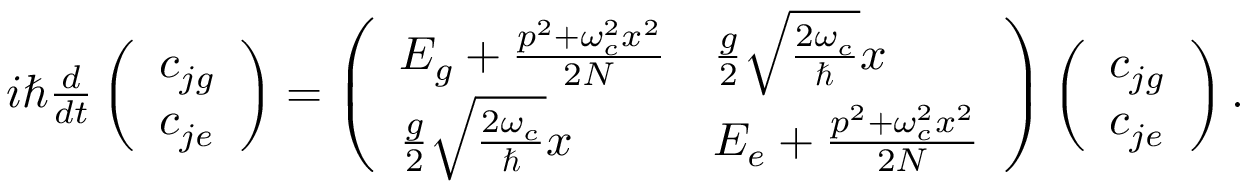<formula> <loc_0><loc_0><loc_500><loc_500>\begin{array} { r } { i \hbar { } d } { d t } \left ( \begin{array} { l } { c _ { j g } } \\ { c _ { j e } } \end{array} \right ) = \left ( \begin{array} { l l } { E _ { g } + \frac { p ^ { 2 } + \omega _ { c } ^ { 2 } x ^ { 2 } } { 2 N } } & { \frac { g } { 2 } \sqrt { \frac { 2 \omega _ { c } } { } } x } \\ { \frac { g } { 2 } \sqrt { \frac { 2 \omega _ { c } } { } } x } & { E _ { e } + \frac { p ^ { 2 } + \omega _ { c } ^ { 2 } x ^ { 2 } } { 2 N } } \end{array} \right ) \left ( \begin{array} { l } { c _ { j g } } \\ { c _ { j e } } \end{array} \right ) . } \end{array}</formula> 